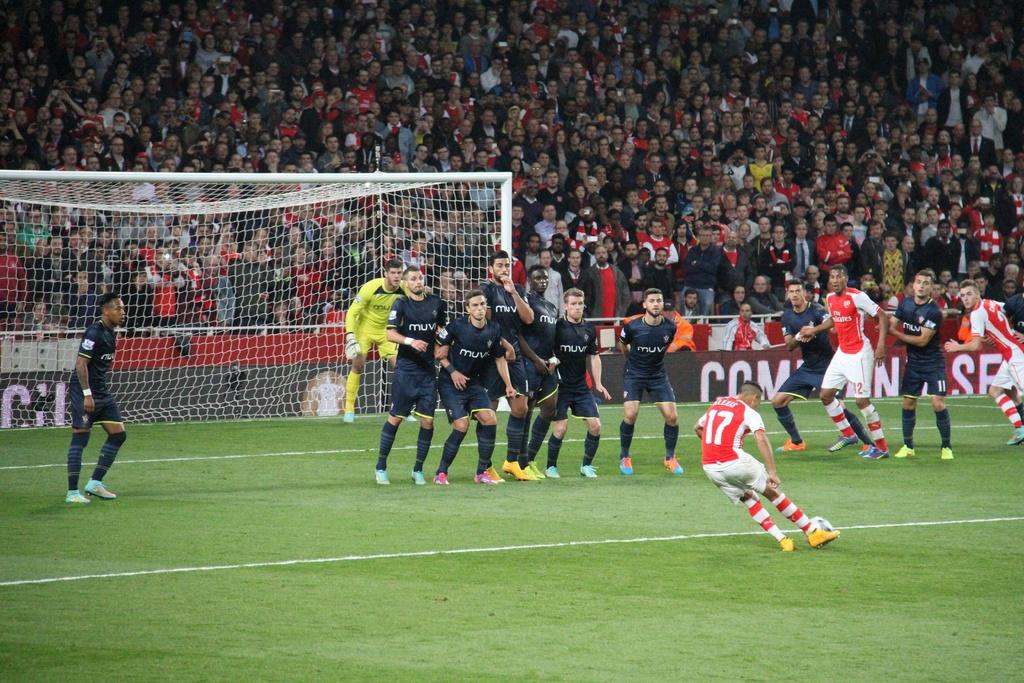What sport are the players in the image participating in? The players in the image are participating in football. Where are the football players located? The football players are on a ground. Can you describe the surroundings of the football ground? There is a huge crowd behind the ground in the image. What type of company is the crook running in the image? There is no crook or company present in the image; it features football players on a ground with a crowd in the background. 